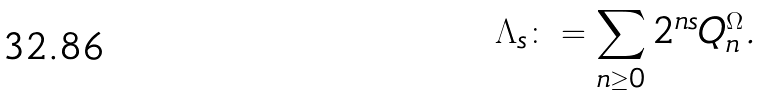Convert formula to latex. <formula><loc_0><loc_0><loc_500><loc_500>\Lambda _ { s } \colon = \sum _ { n \geq 0 } 2 ^ { n s } Q _ { n } ^ { \Omega } .</formula> 